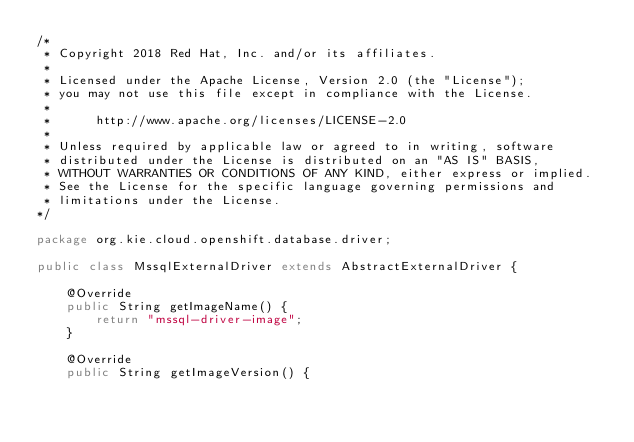<code> <loc_0><loc_0><loc_500><loc_500><_Java_>/*
 * Copyright 2018 Red Hat, Inc. and/or its affiliates.
 *
 * Licensed under the Apache License, Version 2.0 (the "License");
 * you may not use this file except in compliance with the License.
 *
 *      http://www.apache.org/licenses/LICENSE-2.0
 *
 * Unless required by applicable law or agreed to in writing, software
 * distributed under the License is distributed on an "AS IS" BASIS,
 * WITHOUT WARRANTIES OR CONDITIONS OF ANY KIND, either express or implied.
 * See the License for the specific language governing permissions and
 * limitations under the License.
*/

package org.kie.cloud.openshift.database.driver;

public class MssqlExternalDriver extends AbstractExternalDriver {

    @Override
    public String getImageName() {
        return "mssql-driver-image";
    }

    @Override
    public String getImageVersion() {</code> 